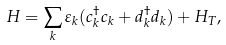Convert formula to latex. <formula><loc_0><loc_0><loc_500><loc_500>H = \sum _ { k } \varepsilon _ { k } ( c ^ { \dagger } _ { k } c _ { k } + d ^ { \dagger } _ { k } d _ { k } ) + H _ { T } ,</formula> 